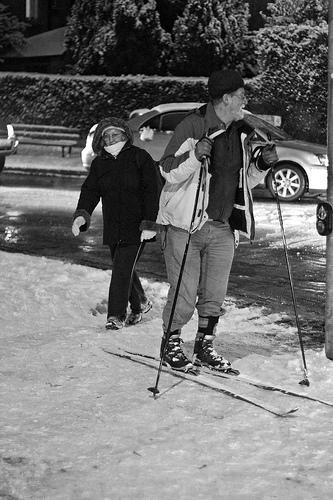How many people are shown?
Give a very brief answer. 2. How many cars are shown?
Give a very brief answer. 1. 